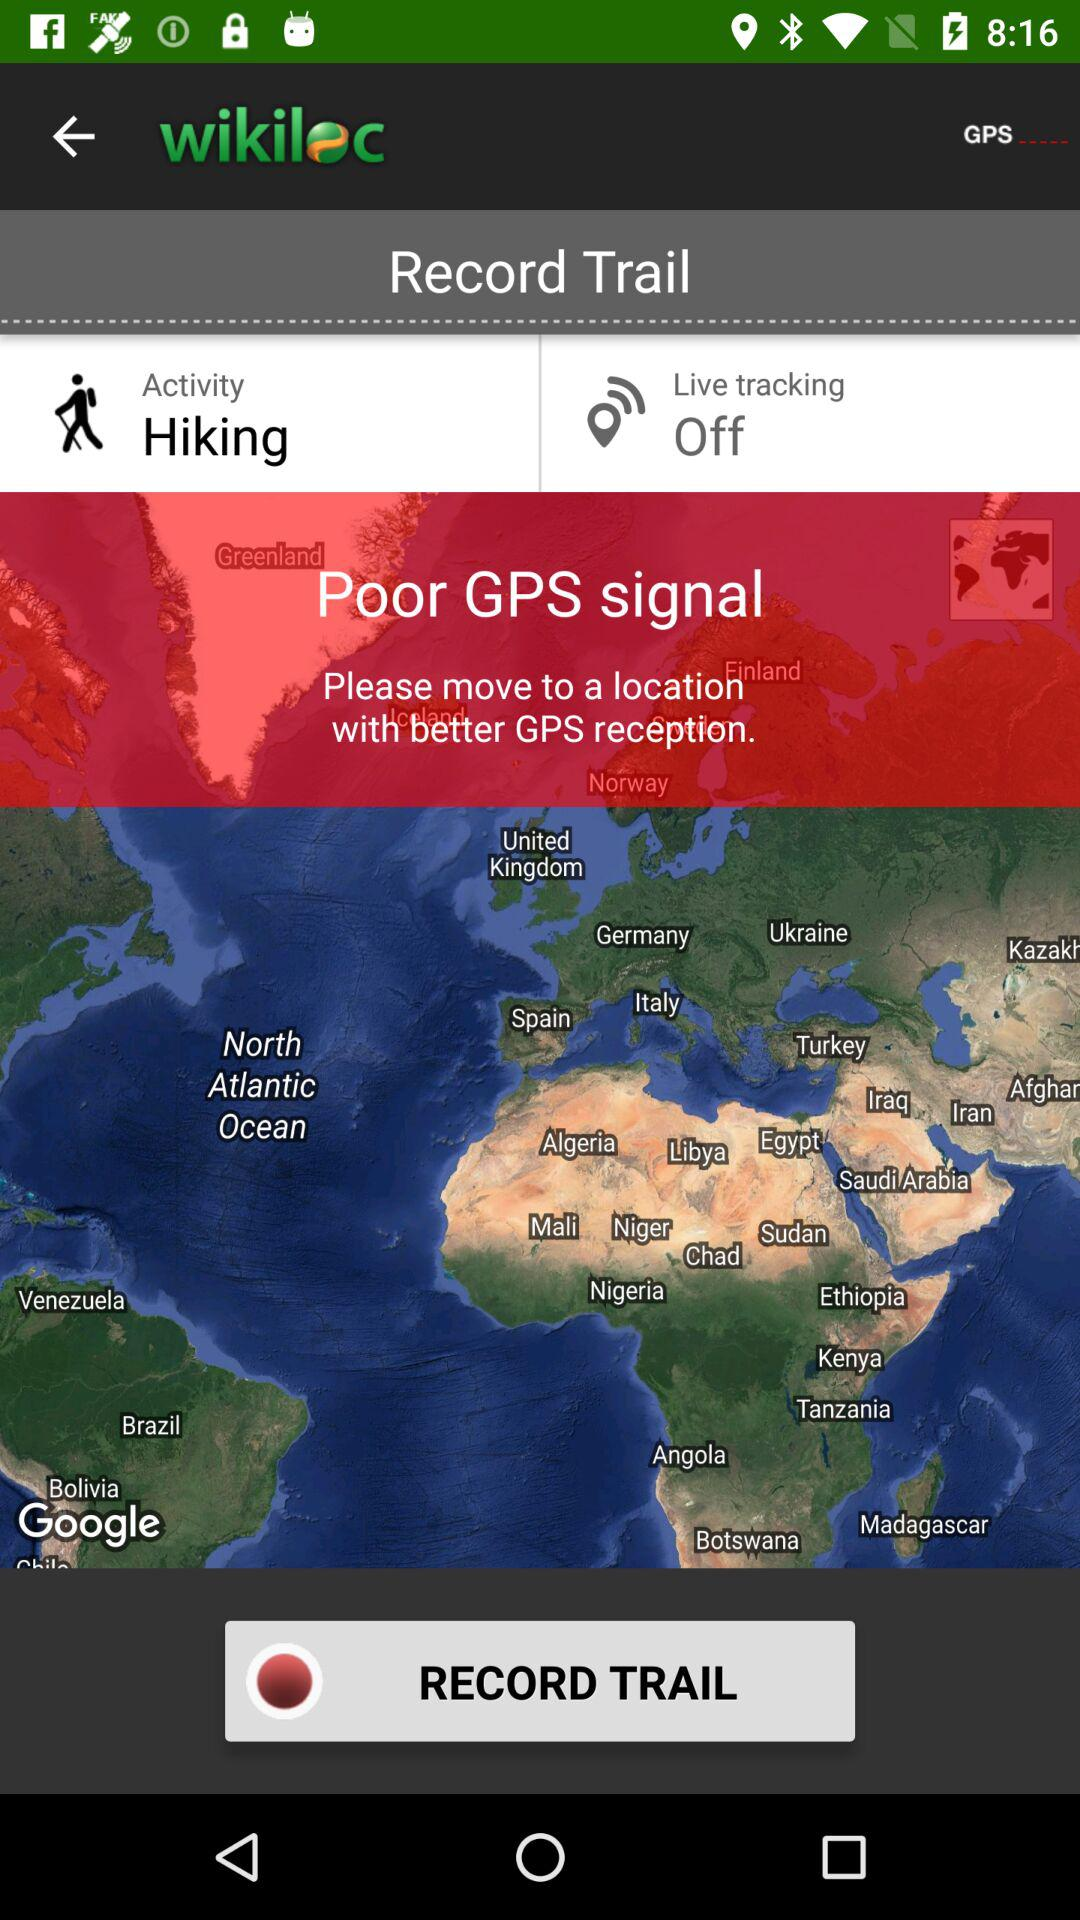How many more options are there for the activity setting than the live tracking setting?
Answer the question using a single word or phrase. 1 